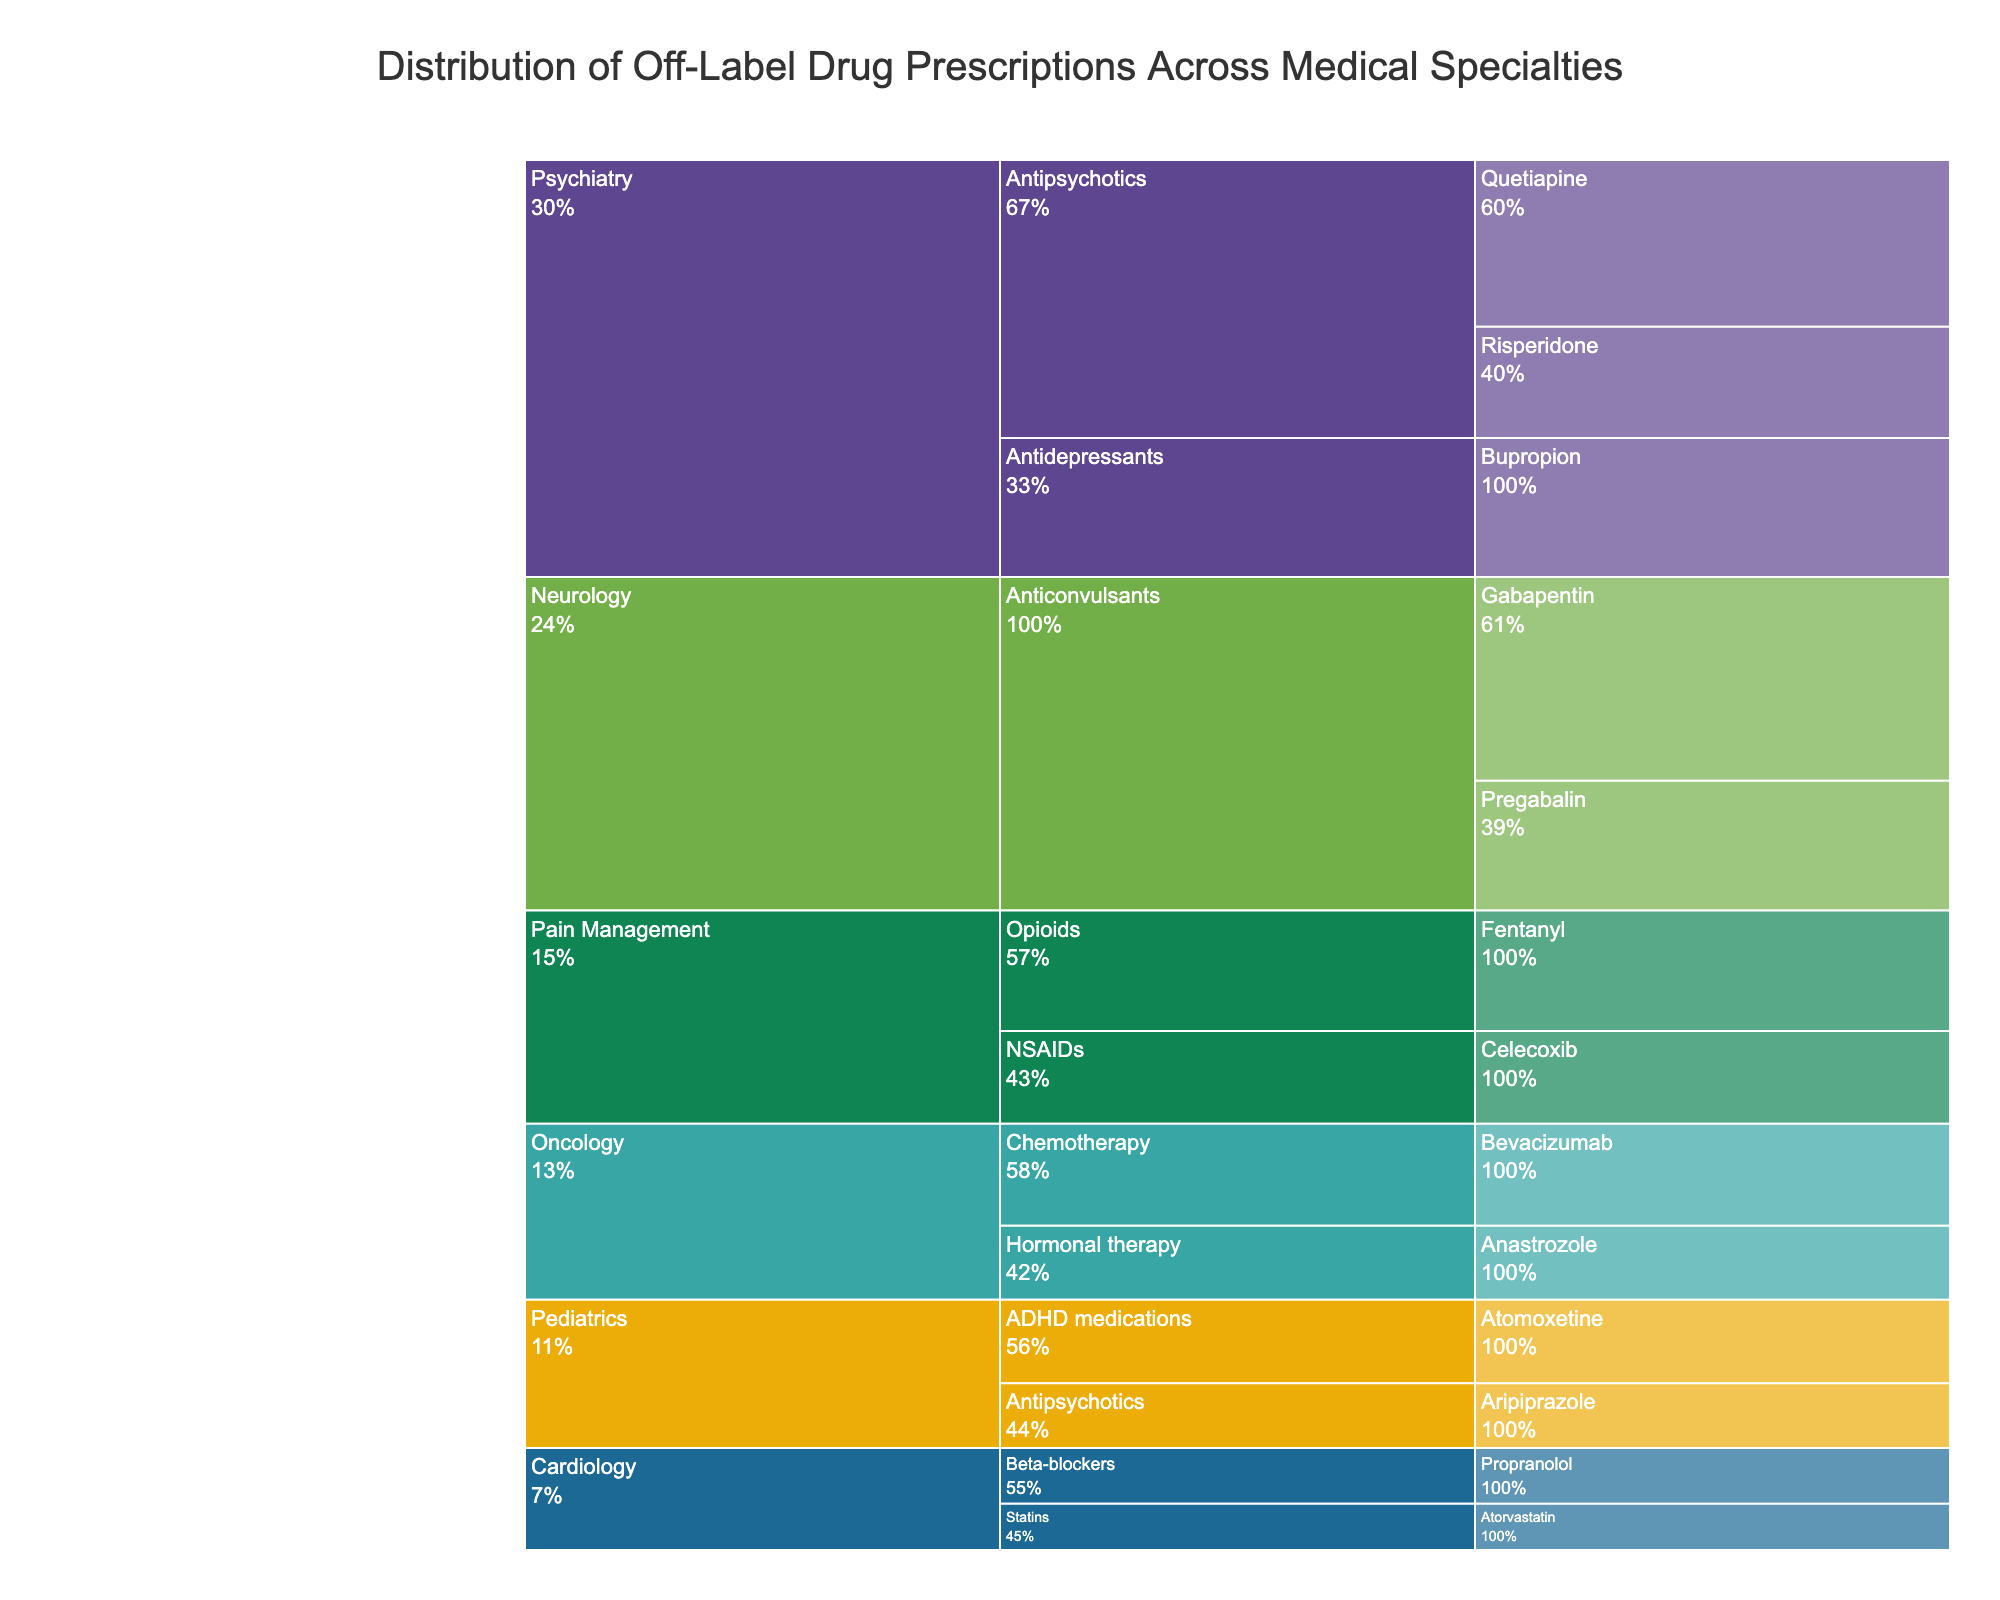What is the title of the chart? The title of the chart is usually positioned at the top and provides a summary of what the chart is about. The title in this case is "Distribution of Off-Label Drug Prescriptions Across Medical Specialties"
Answer: Distribution of Off-Label Drug Prescriptions Across Medical Specialties Which specialty has the highest percentage of off-label drug prescriptions? To find this, look at the height of the sections within each specialty. Neurology has the highest single percentage, with Gabapentin at 22%.
Answer: Neurology How do the percentages of Antipsychotics in Psychiatry compare to the Anticonvulsants in Neurology? Add the percentages for Antipsychotics in Psychiatry (Quetiapine 18% + Risperidone 12% = 30%) and for Anticonvulsants in Neurology (Gabapentin 22% + Pregabalin 14% = 36%). Compare the totals 30% and 36%.
Answer: Neurology has a higher percentage Which drug category in Pain Management has the lower percentage of off-label prescriptions? Examine the percentages within Pain Management. Compare Fentanyl (13%) with Celecoxib (10%).
Answer: NSAIDs (Celecoxib) What is the combined percentage for Psychiatry and Pediatrics? Combine the percentages for all drugs within these two specialties. Psychiatry: 18% + 12% + 15% = 45%, and Pediatrics: 9% + 7% = 16%. Adding these, 45% + 16%.
Answer: 61% Is the percentage of Atorvastatin in Cardiology higher or lower than the percentage of Aripiprazole in Pediatrics? Compare Atorvastatin in Cardiology (5%) with Aripiprazole in Pediatrics (7%).
Answer: Lower Which Oncology category drug has a higher off-label prescription percentage? Compare the percentages of Bevacizumab (11%) and Anastrozole (8%) in Oncology.
Answer: Chemotherapy (Bevacizumab) How is the percentage contribution of Antipsychotics split between Quetiapine and Risperidone in Psychiatry? Look at the individual percentages within Antipsychotics in Psychiatry to see the split: Quetiapine (18%) and Risperidone (12%).
Answer: Quetiapine: 18% and Risperidone: 12% Which specialty uses the fewest drugs in off-label prescriptions in this data? Count the number of unique drugs listed under each specialty. Cardiology lists only two drugs: Propranolol and Atorvastatin.
Answer: Cardiology 